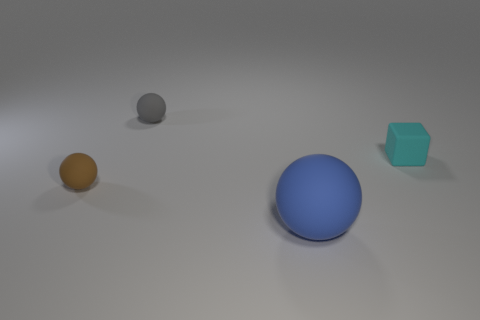There is a gray sphere; is it the same size as the matte thing in front of the brown rubber ball?
Provide a short and direct response. No. There is a object that is on the right side of the gray matte sphere and on the left side of the tiny cyan rubber block; what is its size?
Offer a terse response. Large. Are there any other brown balls that have the same material as the large ball?
Your answer should be compact. Yes. What shape is the tiny cyan object?
Ensure brevity in your answer.  Cube. Do the brown thing and the cyan rubber thing have the same size?
Your answer should be compact. Yes. What number of other things are there of the same shape as the cyan rubber thing?
Provide a short and direct response. 0. What shape is the rubber thing that is to the right of the blue ball?
Ensure brevity in your answer.  Cube. There is a matte object that is to the left of the gray sphere; is its shape the same as the matte object in front of the brown object?
Provide a short and direct response. Yes. Is the number of gray balls behind the small cyan block the same as the number of cyan matte cubes?
Your response must be concise. Yes. Is there any other thing that has the same size as the blue matte ball?
Give a very brief answer. No. 